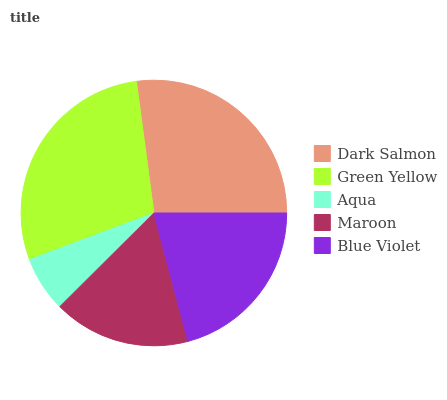Is Aqua the minimum?
Answer yes or no. Yes. Is Green Yellow the maximum?
Answer yes or no. Yes. Is Green Yellow the minimum?
Answer yes or no. No. Is Aqua the maximum?
Answer yes or no. No. Is Green Yellow greater than Aqua?
Answer yes or no. Yes. Is Aqua less than Green Yellow?
Answer yes or no. Yes. Is Aqua greater than Green Yellow?
Answer yes or no. No. Is Green Yellow less than Aqua?
Answer yes or no. No. Is Blue Violet the high median?
Answer yes or no. Yes. Is Blue Violet the low median?
Answer yes or no. Yes. Is Green Yellow the high median?
Answer yes or no. No. Is Maroon the low median?
Answer yes or no. No. 